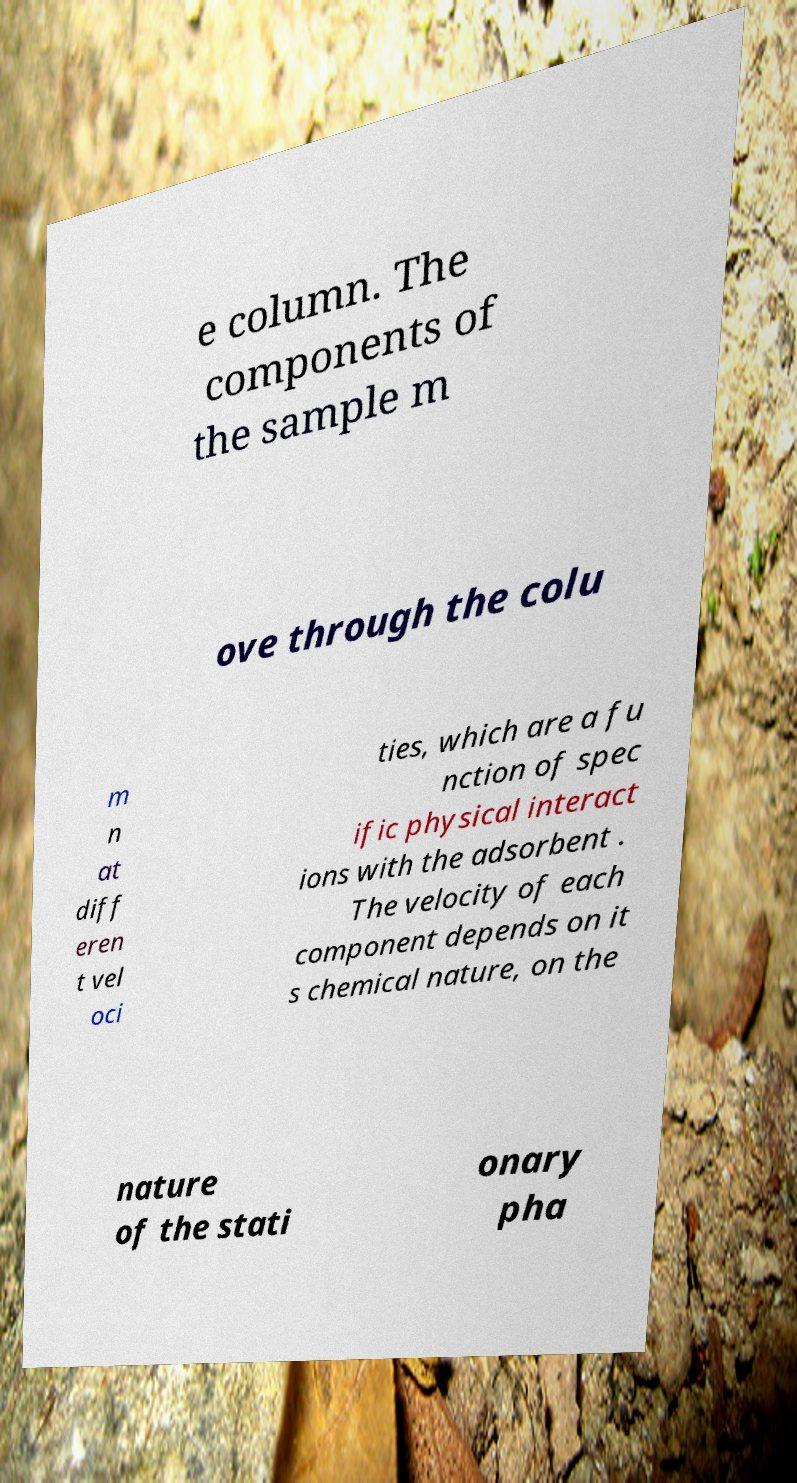Can you accurately transcribe the text from the provided image for me? e column. The components of the sample m ove through the colu m n at diff eren t vel oci ties, which are a fu nction of spec ific physical interact ions with the adsorbent . The velocity of each component depends on it s chemical nature, on the nature of the stati onary pha 